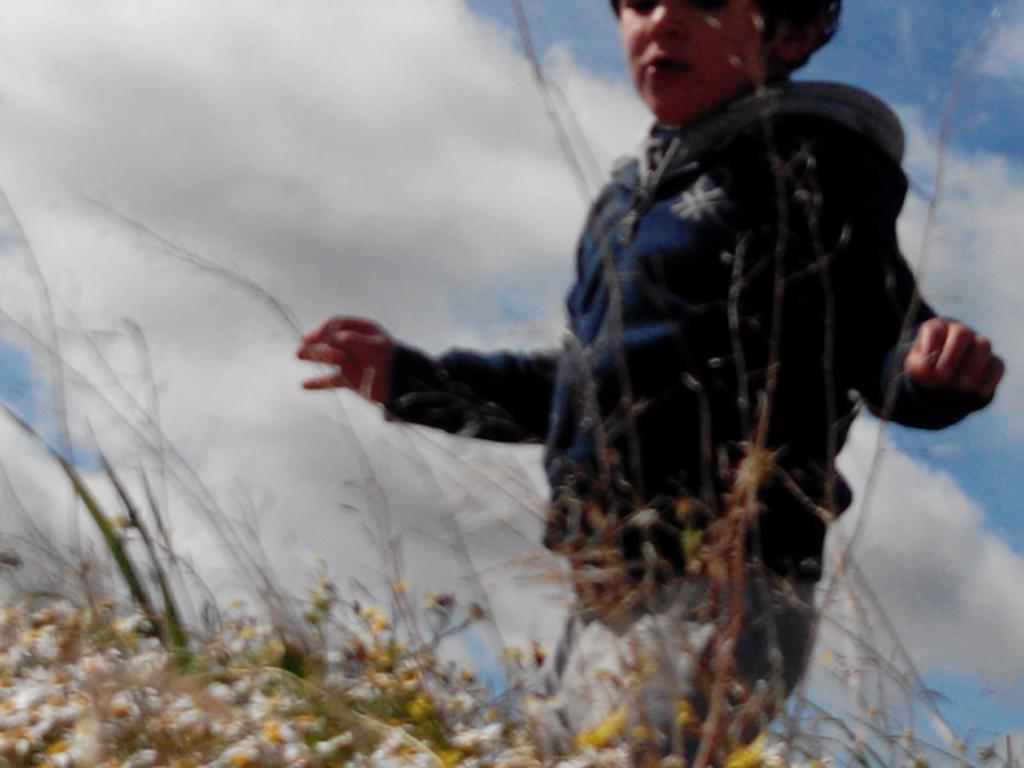In one or two sentences, can you explain what this image depicts? In this image I can see the person standing and the person is wearing navy blue color jacket and I can see few flowers in yellow color. In the background the sky is in white and blue color. 